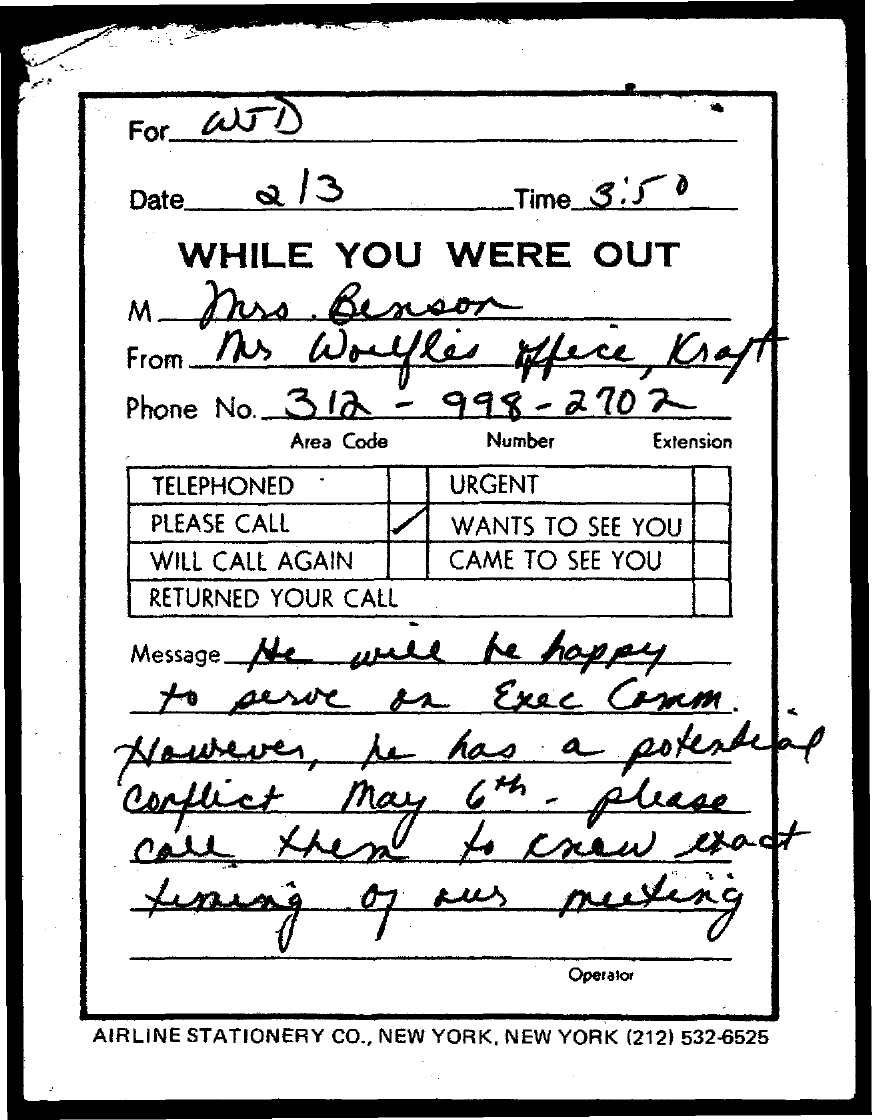Highlight a few significant elements in this photo. The person responsible is WJD. The time is currently 3:50 PM. There is a potential conflict on May 6th. The phone number is 312-998-2702. What is the date? 2/3...," is a question asking for information about the current date. 